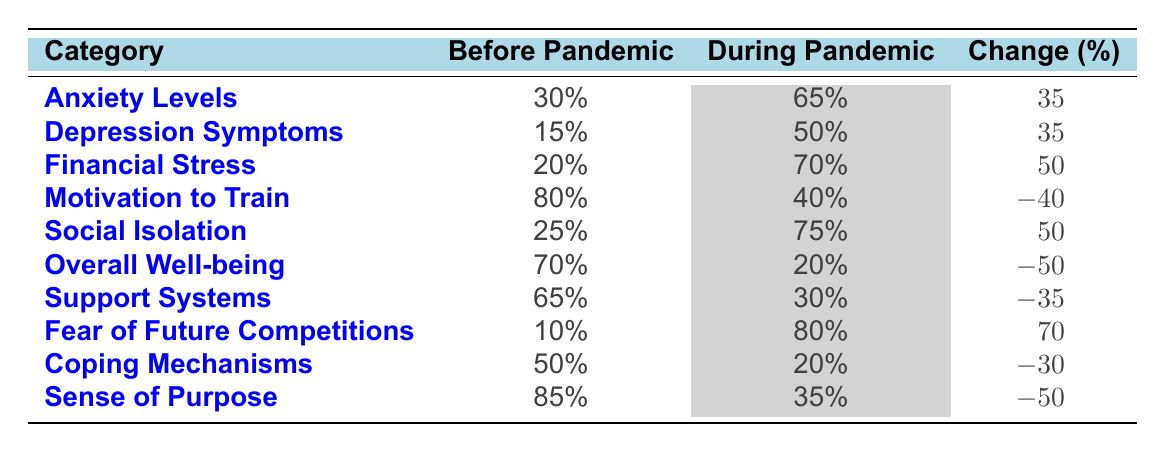What was the percentage increase in athletes reporting anxiety levels during the pandemic? The table shows that before the pandemic, anxiety levels were 30%, and during the pandemic, they increased to 65%. The change is calculated as 65% - 30% = 35%.
Answer: 35% What is the percentage of athletes who experienced a decrease in motivation to train during the pandemic? The table indicates that motivation to train was at 80% before the pandemic and dropped to 40% during the pandemic. The change is calculated as 40% - 80% = -40%.
Answer: -40% Did more athletes report financial stress during the pandemic compared to before? The table shows financial stress at 20% before the pandemic and 70% during, indicating a significant increase. Therefore, the statement is true.
Answer: Yes What was the overall change in the percentage of athletes reporting a sense of purpose during the pandemic? The percentage of athletes reporting a sense of purpose dropped from 85% to 35%. The change is calculated as 35% - 85% = -50%.
Answer: -50% What percentage of athletes felt socially isolated during the pandemic, and how does it compare to before the pandemic? Social isolation was reported at 25% before and 75% during the pandemic, an increase of 50%.
Answer: 75%, increased by 50% What is the difference in the percentage of athletes reporting coping mechanisms before and during the pandemic? Athletes reported 50% using coping mechanisms before and only 20% during. The difference is calculated as 20% - 50% = -30%.
Answer: -30% Was the fear of future competitions more prevalent during the pandemic than before? The table shows fear of future competitions at 10% before and 80% during, indicating a significant increase. Therefore, the statement is true.
Answer: Yes What is the average percentage change across all categories listed in the table? The changes in percentage are: 35, 35, 50, -40, 50, -50, -35, 70, -30, -50. First, sum these changes: 35 + 35 + 50 + (-40) + 50 + (-50) + (-35) + 70 + (-30) + (-50) = 10. Then, divide by the number of categories (10): 10 / 10 = 1.
Answer: 1 What category had the highest percentage change during the pandemic? By reviewing the changes in the table, the category with the highest change is "Fear of Future Competitions" at 70%.
Answer: Fear of Future Competitions How much less did athletes feel supported during the pandemic compared to before? Support systems decreased from 65% to 30%, which is a change of 30% - 65% = -35%. Thus, they felt 35% less supported.
Answer: 35% less supported 